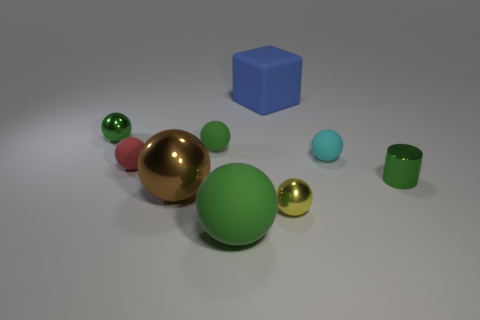How many green spheres must be subtracted to get 1 green spheres? 2 Subtract all purple blocks. How many green balls are left? 3 Subtract all brown balls. How many balls are left? 6 Subtract all tiny yellow metallic spheres. How many spheres are left? 6 Subtract 3 balls. How many balls are left? 4 Subtract all gray spheres. Subtract all blue cubes. How many spheres are left? 7 Add 1 small yellow matte cylinders. How many objects exist? 10 Subtract all cylinders. How many objects are left? 8 Subtract all yellow things. Subtract all big blue matte objects. How many objects are left? 7 Add 4 tiny cyan spheres. How many tiny cyan spheres are left? 5 